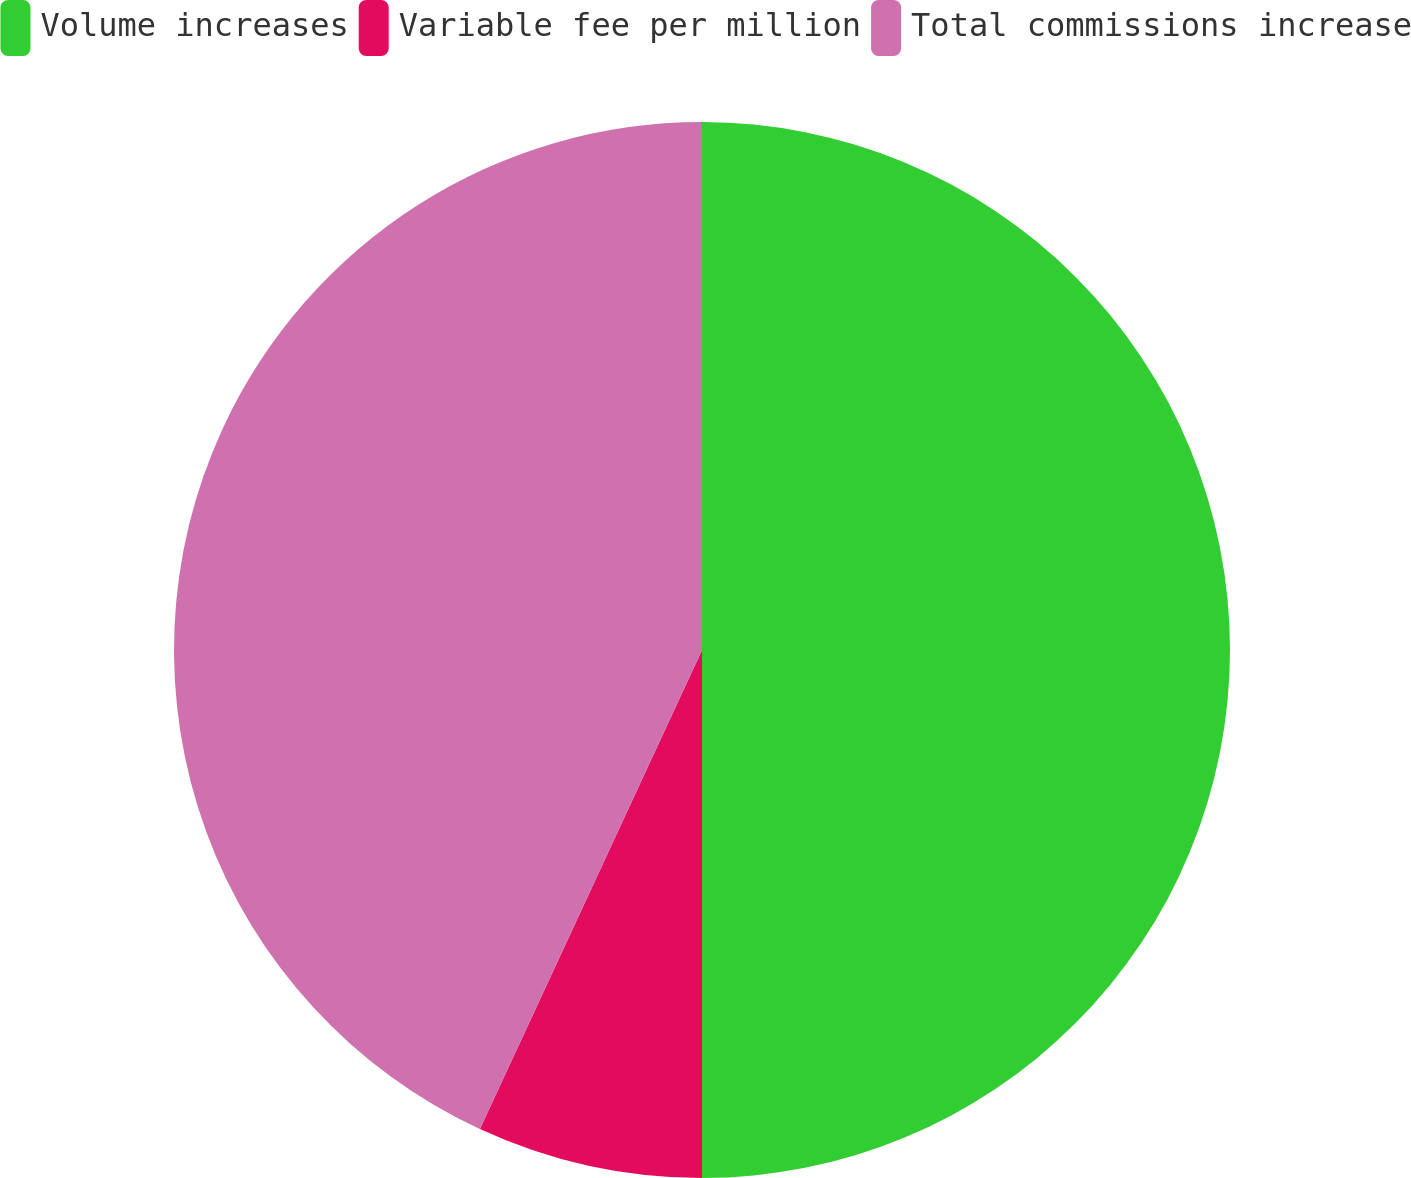Convert chart to OTSL. <chart><loc_0><loc_0><loc_500><loc_500><pie_chart><fcel>Volume increases<fcel>Variable fee per million<fcel>Total commissions increase<nl><fcel>50.0%<fcel>6.91%<fcel>43.09%<nl></chart> 